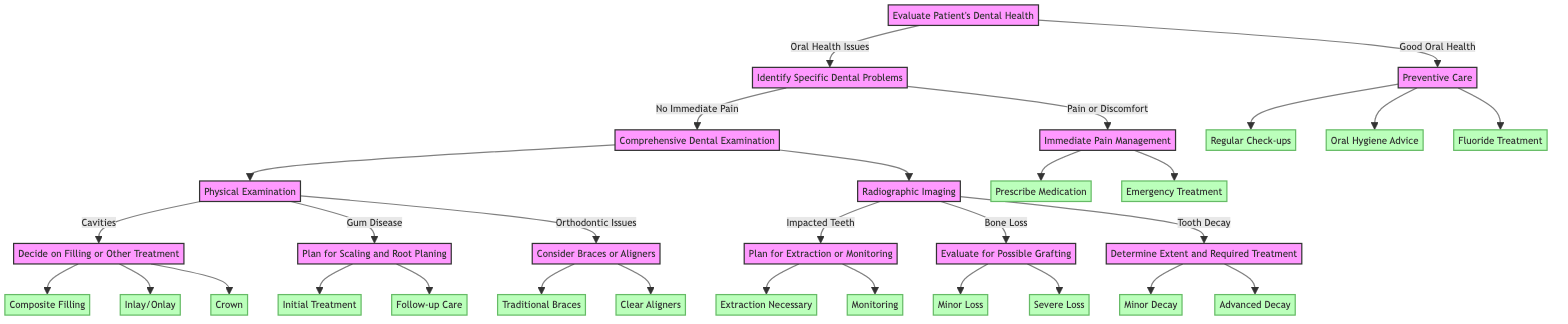What is the starting point of the treatment plan? The starting point of the treatment plan as per the diagram is "Evaluate Patient's Dental Health." This is the first node from which all other paths in the decision tree begin.
Answer: Evaluate Patient's Dental Health How many options does the "Preventive Care" node have? The "Preventive Care" node has three options: Regular Check-ups, Oral Hygiene Advice, and Fluoride Treatment. This can be counted directly from the branches leading from the "Preventive Care" node.
Answer: 3 What follows after identifying "No Immediate Pain"? After identifying "No Immediate Pain," the next step is "Comprehensive Dental Examination." This follows directly in the flow of the decision tree from the "Identify Specific Dental Problems" node.
Answer: Comprehensive Dental Examination What treatment option is considered after finding cavities? After finding cavities, the treatment option considered is "Decide on Filling or Other Treatment." This is a direct branch following the "Physical Examination" node.
Answer: Decide on Filling or Other Treatment What are the two choices under "Radiographic Imaging"? The two choices under "Radiographic Imaging" are "Impacted Teeth" and "Bone Loss." These represent the possible situations that can be identified from radiographic assessments and lead to further actions.
Answer: Impacted Teeth, Bone Loss Which node leads to "Emergency Treatment"? The node that leads to "Emergency Treatment" is "Immediate Pain Management." If pain or discomfort is identified in the flow, this option branches out directly from that node.
Answer: Immediate Pain Management What must be evaluated if "Bone Loss" is identified? If "Bone Loss" is identified, the next step is to "Evaluate for Possible Grafting." This is necessary to determine the appropriate treatment for the identified bone condition.
Answer: Evaluate for Possible Grafting Why would a patient be referred to an orthodontist? A patient would be referred to an orthodontist if "Traditional Braces" is chosen as an option under "Consider Braces or Aligners." This reflects the path taken when orthodontic treatment is deemed necessary.
Answer: Refer to Orthodontist What follows if "Advanced Decay" is determined? If "Advanced Decay" is determined, the next step is to "Consider Root Canal or Extraction." This specifies the treatment decisions based on the extent of tooth decay identified in the examination process.
Answer: Consider Root Canal or Extraction 